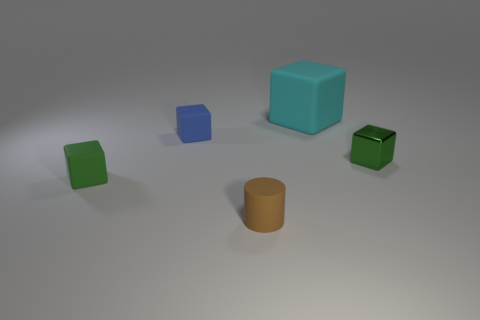Subtract all blue blocks. How many blocks are left? 3 Subtract all small blue cubes. How many cubes are left? 3 Subtract all purple blocks. Subtract all yellow spheres. How many blocks are left? 4 Add 5 big rubber blocks. How many objects exist? 10 Subtract all blocks. How many objects are left? 1 Add 5 big red rubber spheres. How many big red rubber spheres exist? 5 Subtract 1 cyan blocks. How many objects are left? 4 Subtract all small metal cubes. Subtract all small brown cylinders. How many objects are left? 3 Add 5 green objects. How many green objects are left? 7 